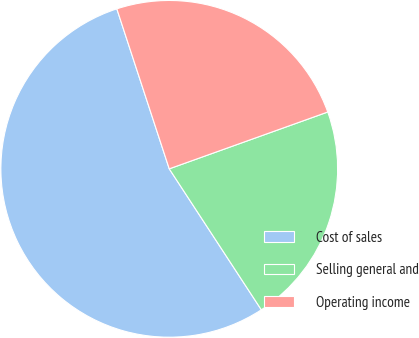Convert chart to OTSL. <chart><loc_0><loc_0><loc_500><loc_500><pie_chart><fcel>Cost of sales<fcel>Selling general and<fcel>Operating income<nl><fcel>54.17%<fcel>21.27%<fcel>24.56%<nl></chart> 